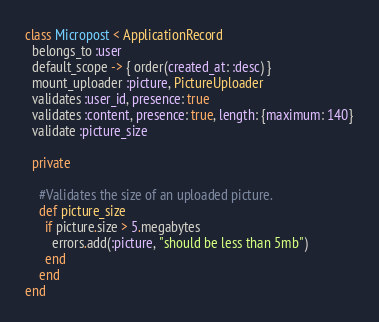Convert code to text. <code><loc_0><loc_0><loc_500><loc_500><_Ruby_>class Micropost < ApplicationRecord
  belongs_to :user
  default_scope -> { order(created_at: :desc) }
  mount_uploader :picture, PictureUploader
  validates :user_id, presence: true
  validates :content, presence: true, length: {maximum: 140}
  validate :picture_size
  
  private
    
    #Validates the size of an uploaded picture.
    def picture_size
      if picture.size > 5.megabytes
        errors.add(:picture, "should be less than 5mb")
      end 
    end 
end
</code> 